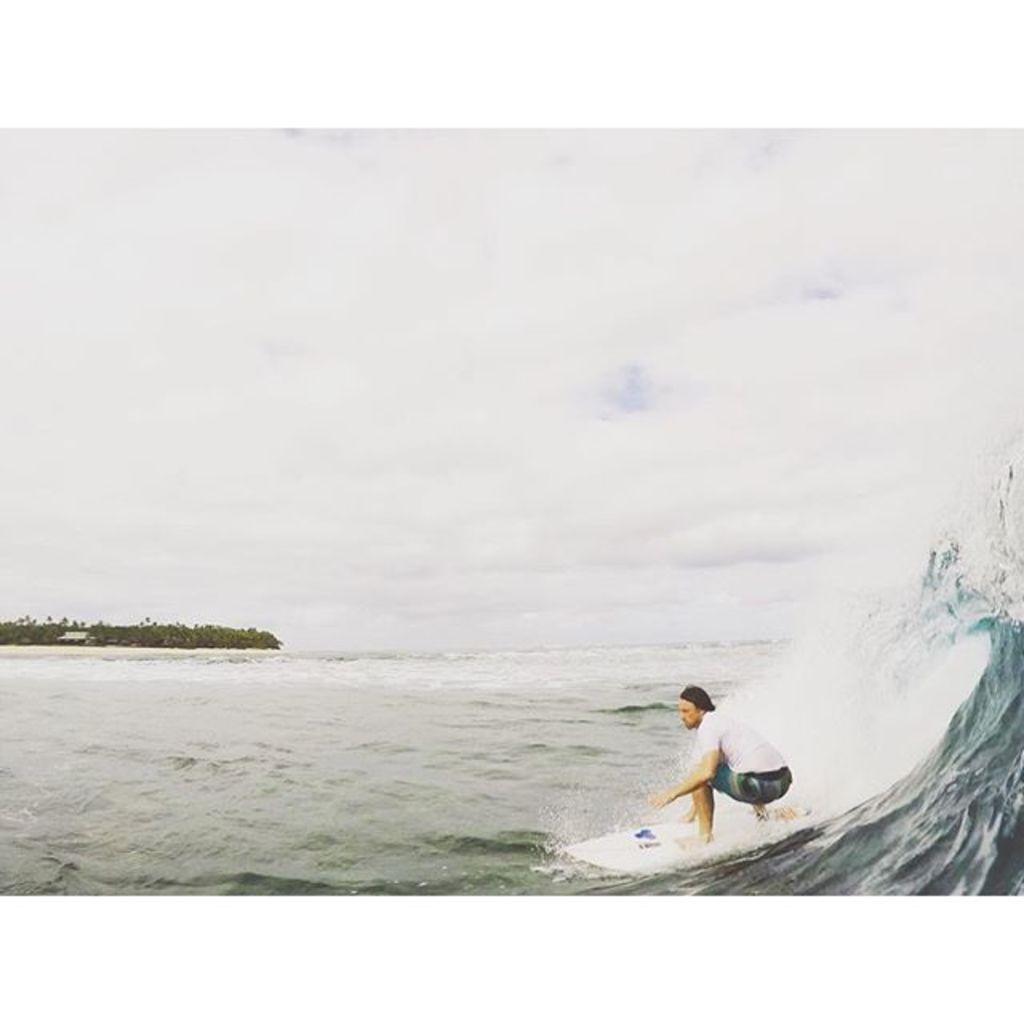Could you give a brief overview of what you see in this image? In the center of the image we can see one person is surfing on the water. In the background, we can see the sky, clouds, trees, water and a few other objects. 